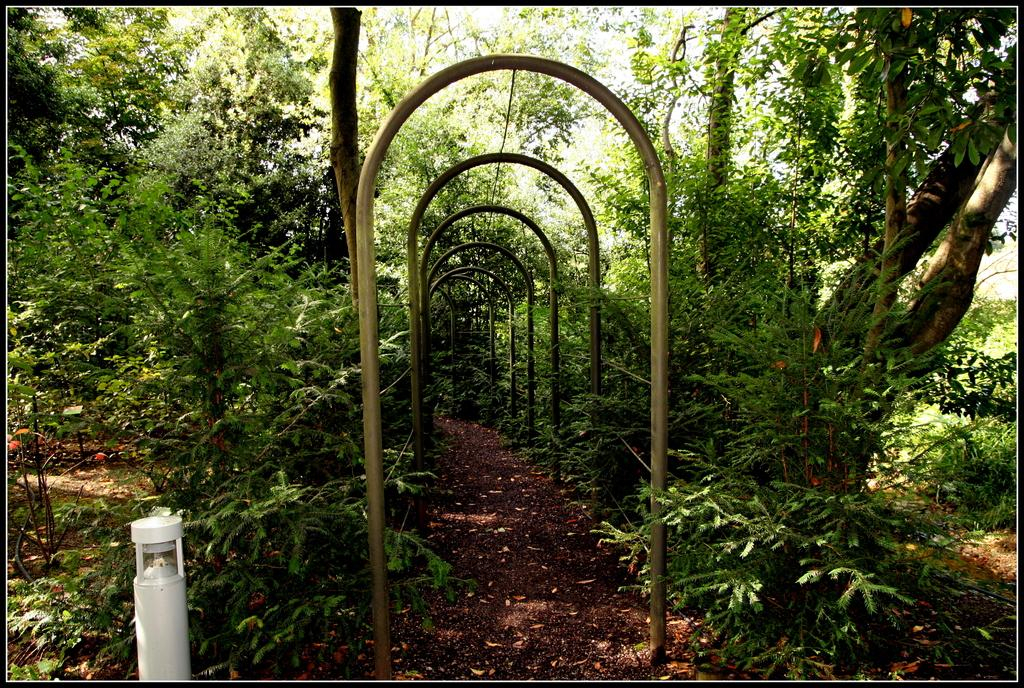What is the primary feature of the landscape in the image? There are many trees in the image. What can be seen in the middle of the image? There is a path in the middle of the image. What kind of structure is present on the path? There is an arch-like structure made up of multiple poles on the path. What is the purpose of the water sprinkler in the image? The purpose of the water sprinkler in the image is not specified, but it could be used for watering plants or cooling the area. What role does the actor play in the game depicted in the image? There is no actor or game present in the image; it features trees, a path, an arch-like structure, and a water sprinkler. 